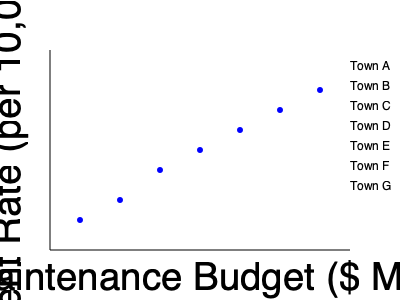As the state government official overseeing town managers' performance, you're analyzing the relationship between street maintenance budgets and road accident rates across seven towns. Based on the scatter plot, what conclusion can you draw about the effectiveness of increased street maintenance budgets in reducing road accident rates? To analyze the relationship between street maintenance budgets and road accident rates, we need to follow these steps:

1. Observe the general trend of the data points:
   The scatter plot shows a clear downward trend from left to right.

2. Interpret the axes:
   - X-axis: Street Maintenance Budget ($ Millions)
   - Y-axis: Road Accident Rate (per 10,000 vehicles)

3. Understand the relationship:
   As we move from left to right (increasing budget), the data points move downward (decreasing accident rate).

4. Analyze the correlation:
   There appears to be a strong negative correlation between the street maintenance budget and road accident rates.

5. Consider the implications:
   Towns that allocate larger budgets for street maintenance tend to have lower road accident rates.

6. Evaluate the effectiveness:
   The consistent downward trend suggests that increasing street maintenance budgets is an effective strategy for reducing road accident rates across the seven towns.

7. Draw a conclusion:
   Based on this data, we can conclude that there is strong evidence supporting the effectiveness of increased street maintenance budgets in reducing road accident rates.
Answer: Increased street maintenance budgets are effective in reducing road accident rates. 